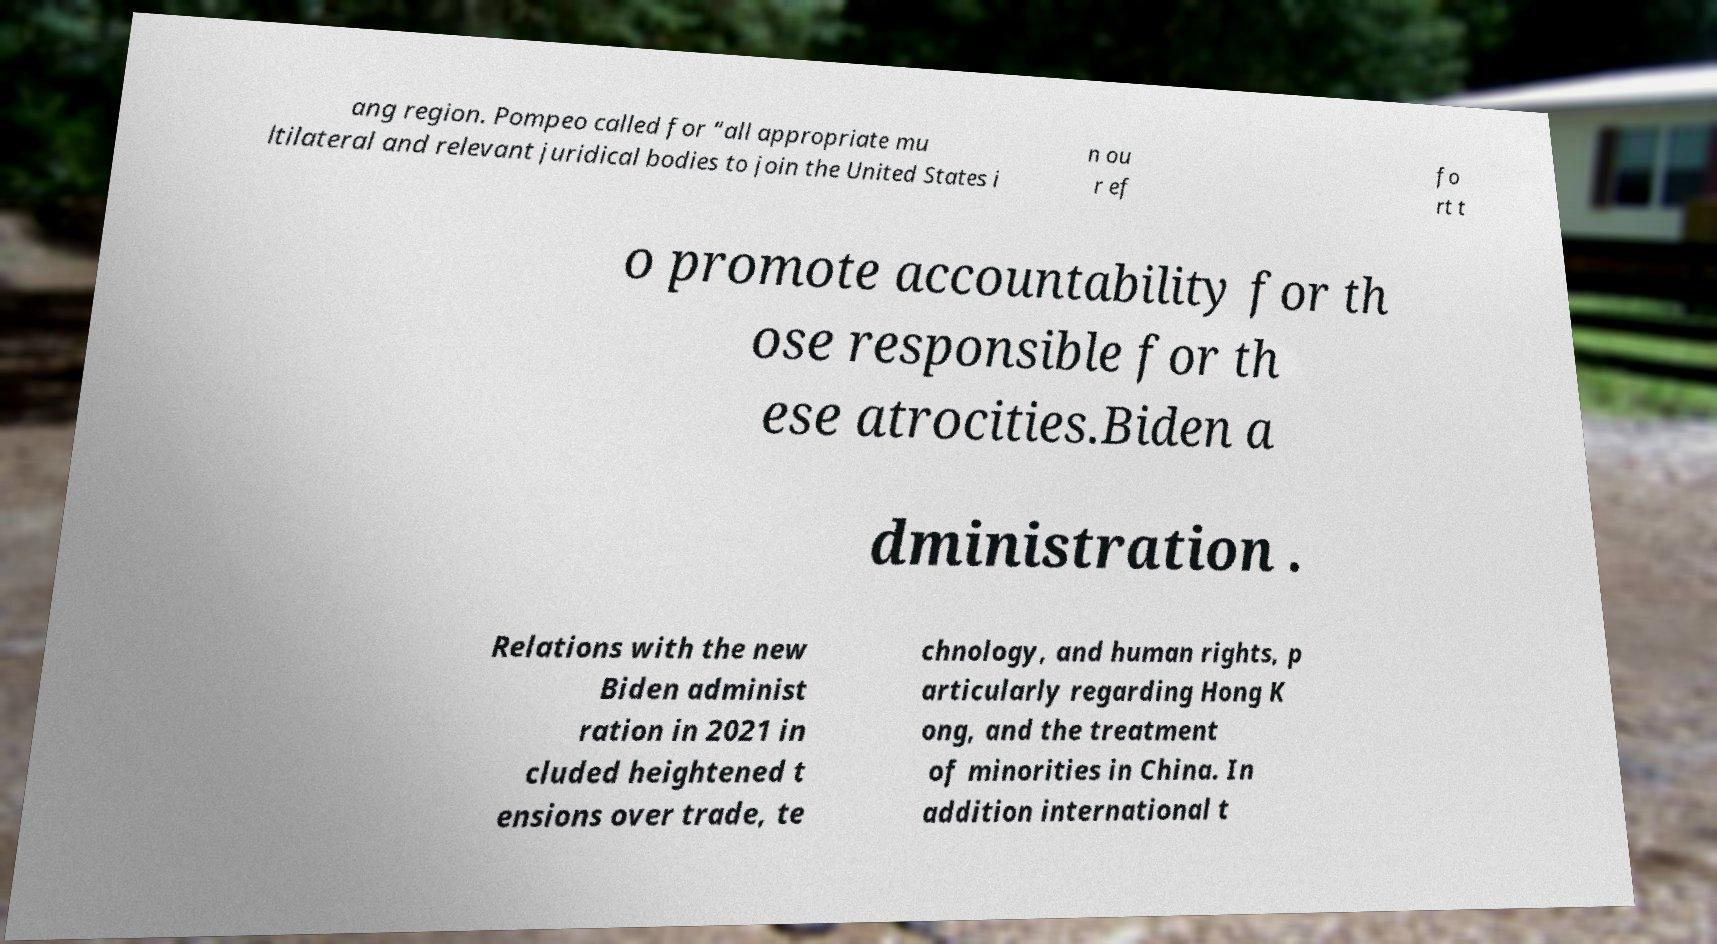Can you read and provide the text displayed in the image?This photo seems to have some interesting text. Can you extract and type it out for me? ang region. Pompeo called for “all appropriate mu ltilateral and relevant juridical bodies to join the United States i n ou r ef fo rt t o promote accountability for th ose responsible for th ese atrocities.Biden a dministration . Relations with the new Biden administ ration in 2021 in cluded heightened t ensions over trade, te chnology, and human rights, p articularly regarding Hong K ong, and the treatment of minorities in China. In addition international t 